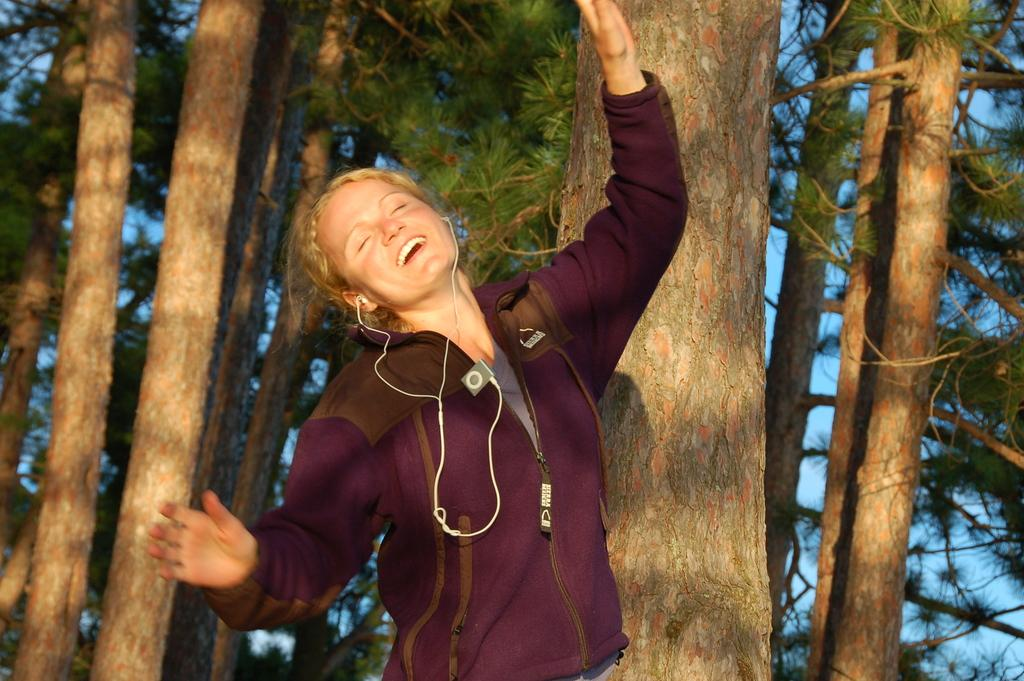Who is present in the image? There is a woman in the image. What is the woman doing in the image? The woman is smiling in the image. What is the woman wearing in the image? The woman is wearing earphones in the image. What can be seen in the background of the image? Trees and the sky are visible in the background of the image. How many hens are visible in the image? There are no hens present in the image. What direction is the woman turning in the image? The woman is not turning in the image; she is facing forward with a smile. 